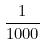Convert formula to latex. <formula><loc_0><loc_0><loc_500><loc_500>\frac { 1 } { 1 0 0 0 }</formula> 